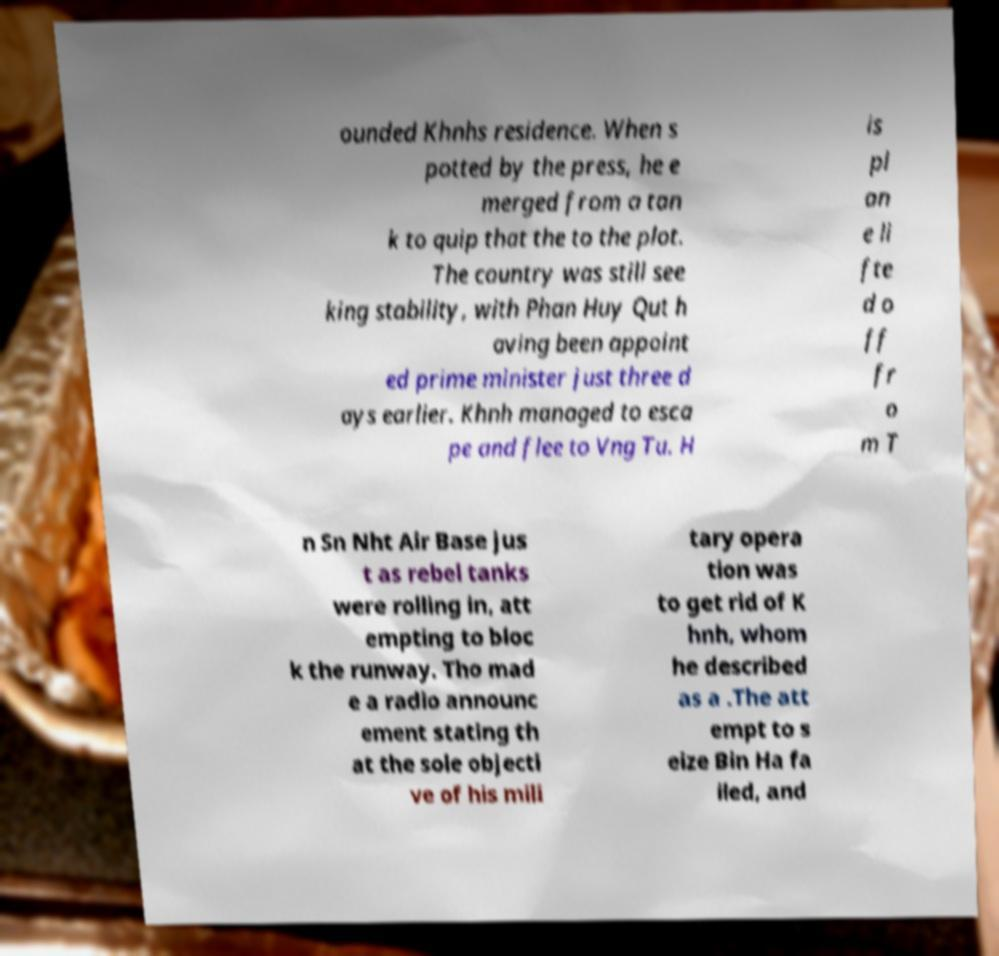Can you accurately transcribe the text from the provided image for me? ounded Khnhs residence. When s potted by the press, he e merged from a tan k to quip that the to the plot. The country was still see king stability, with Phan Huy Qut h aving been appoint ed prime minister just three d ays earlier. Khnh managed to esca pe and flee to Vng Tu. H is pl an e li fte d o ff fr o m T n Sn Nht Air Base jus t as rebel tanks were rolling in, att empting to bloc k the runway. Tho mad e a radio announc ement stating th at the sole objecti ve of his mili tary opera tion was to get rid of K hnh, whom he described as a .The att empt to s eize Bin Ha fa iled, and 